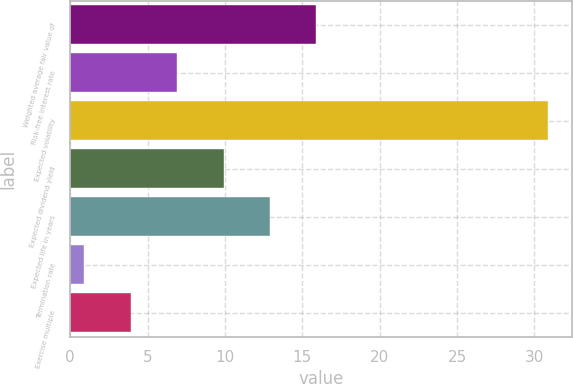<chart> <loc_0><loc_0><loc_500><loc_500><bar_chart><fcel>Weighted average fair value of<fcel>Risk-free interest rate<fcel>Expected volatility<fcel>Expected dividend yield<fcel>Expected life in years<fcel>Termination rate<fcel>Exercise multiple<nl><fcel>15.91<fcel>6.91<fcel>30.9<fcel>9.91<fcel>12.91<fcel>0.91<fcel>3.91<nl></chart> 